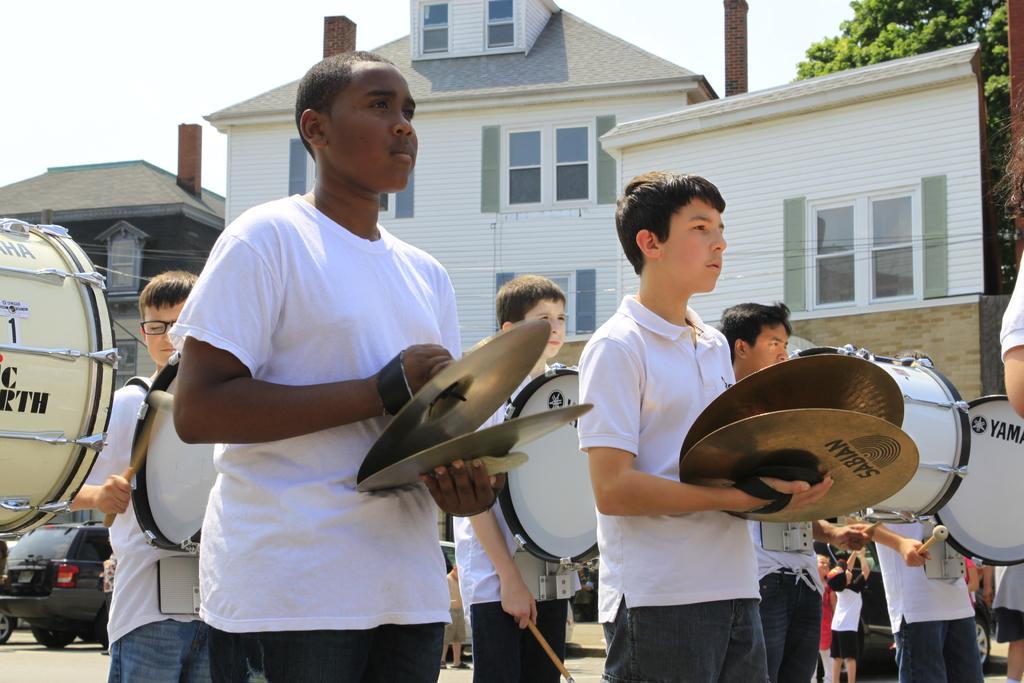What brand of cymbals is shown?
Provide a short and direct response. Sabian. What is the last letter on the drum to the far left?
Provide a short and direct response. H. 